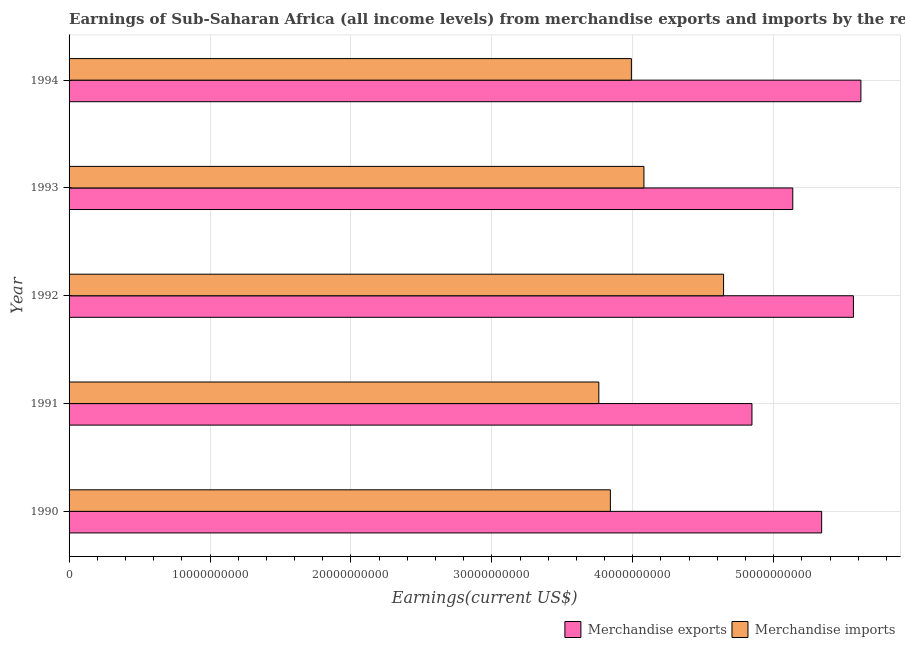How many bars are there on the 2nd tick from the top?
Give a very brief answer. 2. What is the label of the 1st group of bars from the top?
Your answer should be compact. 1994. What is the earnings from merchandise imports in 1994?
Ensure brevity in your answer.  3.99e+1. Across all years, what is the maximum earnings from merchandise imports?
Give a very brief answer. 4.64e+1. Across all years, what is the minimum earnings from merchandise imports?
Provide a succinct answer. 3.76e+1. In which year was the earnings from merchandise exports maximum?
Give a very brief answer. 1994. In which year was the earnings from merchandise imports minimum?
Offer a terse response. 1991. What is the total earnings from merchandise exports in the graph?
Give a very brief answer. 2.65e+11. What is the difference between the earnings from merchandise exports in 1990 and that in 1992?
Make the answer very short. -2.25e+09. What is the difference between the earnings from merchandise imports in 1994 and the earnings from merchandise exports in 1993?
Your response must be concise. -1.15e+1. What is the average earnings from merchandise exports per year?
Provide a succinct answer. 5.30e+1. In the year 1991, what is the difference between the earnings from merchandise exports and earnings from merchandise imports?
Provide a short and direct response. 1.09e+1. In how many years, is the earnings from merchandise imports greater than 24000000000 US$?
Your answer should be compact. 5. Is the difference between the earnings from merchandise exports in 1991 and 1993 greater than the difference between the earnings from merchandise imports in 1991 and 1993?
Make the answer very short. Yes. What is the difference between the highest and the second highest earnings from merchandise imports?
Give a very brief answer. 5.65e+09. What is the difference between the highest and the lowest earnings from merchandise imports?
Your answer should be very brief. 8.85e+09. Is the sum of the earnings from merchandise exports in 1993 and 1994 greater than the maximum earnings from merchandise imports across all years?
Keep it short and to the point. Yes. What does the 1st bar from the top in 1994 represents?
Offer a terse response. Merchandise imports. What does the 1st bar from the bottom in 1994 represents?
Keep it short and to the point. Merchandise exports. How many bars are there?
Your answer should be very brief. 10. What is the difference between two consecutive major ticks on the X-axis?
Ensure brevity in your answer.  1.00e+1. Does the graph contain grids?
Your response must be concise. Yes. Where does the legend appear in the graph?
Offer a terse response. Bottom right. How many legend labels are there?
Your answer should be compact. 2. What is the title of the graph?
Give a very brief answer. Earnings of Sub-Saharan Africa (all income levels) from merchandise exports and imports by the reporting economy. What is the label or title of the X-axis?
Your response must be concise. Earnings(current US$). What is the Earnings(current US$) of Merchandise exports in 1990?
Provide a succinct answer. 5.34e+1. What is the Earnings(current US$) in Merchandise imports in 1990?
Your answer should be compact. 3.84e+1. What is the Earnings(current US$) in Merchandise exports in 1991?
Keep it short and to the point. 4.85e+1. What is the Earnings(current US$) of Merchandise imports in 1991?
Provide a short and direct response. 3.76e+1. What is the Earnings(current US$) in Merchandise exports in 1992?
Give a very brief answer. 5.57e+1. What is the Earnings(current US$) of Merchandise imports in 1992?
Offer a terse response. 4.64e+1. What is the Earnings(current US$) of Merchandise exports in 1993?
Your answer should be compact. 5.14e+1. What is the Earnings(current US$) in Merchandise imports in 1993?
Your answer should be compact. 4.08e+1. What is the Earnings(current US$) in Merchandise exports in 1994?
Make the answer very short. 5.62e+1. What is the Earnings(current US$) in Merchandise imports in 1994?
Give a very brief answer. 3.99e+1. Across all years, what is the maximum Earnings(current US$) in Merchandise exports?
Your answer should be very brief. 5.62e+1. Across all years, what is the maximum Earnings(current US$) of Merchandise imports?
Your response must be concise. 4.64e+1. Across all years, what is the minimum Earnings(current US$) of Merchandise exports?
Give a very brief answer. 4.85e+1. Across all years, what is the minimum Earnings(current US$) in Merchandise imports?
Your response must be concise. 3.76e+1. What is the total Earnings(current US$) of Merchandise exports in the graph?
Your response must be concise. 2.65e+11. What is the total Earnings(current US$) of Merchandise imports in the graph?
Your answer should be very brief. 2.03e+11. What is the difference between the Earnings(current US$) in Merchandise exports in 1990 and that in 1991?
Offer a terse response. 4.95e+09. What is the difference between the Earnings(current US$) in Merchandise imports in 1990 and that in 1991?
Provide a succinct answer. 8.20e+08. What is the difference between the Earnings(current US$) of Merchandise exports in 1990 and that in 1992?
Provide a short and direct response. -2.25e+09. What is the difference between the Earnings(current US$) in Merchandise imports in 1990 and that in 1992?
Offer a very short reply. -8.03e+09. What is the difference between the Earnings(current US$) in Merchandise exports in 1990 and that in 1993?
Offer a terse response. 2.05e+09. What is the difference between the Earnings(current US$) of Merchandise imports in 1990 and that in 1993?
Provide a short and direct response. -2.38e+09. What is the difference between the Earnings(current US$) of Merchandise exports in 1990 and that in 1994?
Give a very brief answer. -2.78e+09. What is the difference between the Earnings(current US$) in Merchandise imports in 1990 and that in 1994?
Give a very brief answer. -1.49e+09. What is the difference between the Earnings(current US$) in Merchandise exports in 1991 and that in 1992?
Your answer should be very brief. -7.20e+09. What is the difference between the Earnings(current US$) of Merchandise imports in 1991 and that in 1992?
Make the answer very short. -8.85e+09. What is the difference between the Earnings(current US$) in Merchandise exports in 1991 and that in 1993?
Your answer should be very brief. -2.90e+09. What is the difference between the Earnings(current US$) in Merchandise imports in 1991 and that in 1993?
Offer a terse response. -3.20e+09. What is the difference between the Earnings(current US$) in Merchandise exports in 1991 and that in 1994?
Provide a succinct answer. -7.73e+09. What is the difference between the Earnings(current US$) of Merchandise imports in 1991 and that in 1994?
Give a very brief answer. -2.31e+09. What is the difference between the Earnings(current US$) in Merchandise exports in 1992 and that in 1993?
Your answer should be compact. 4.30e+09. What is the difference between the Earnings(current US$) of Merchandise imports in 1992 and that in 1993?
Provide a short and direct response. 5.65e+09. What is the difference between the Earnings(current US$) in Merchandise exports in 1992 and that in 1994?
Provide a succinct answer. -5.30e+08. What is the difference between the Earnings(current US$) of Merchandise imports in 1992 and that in 1994?
Provide a succinct answer. 6.54e+09. What is the difference between the Earnings(current US$) of Merchandise exports in 1993 and that in 1994?
Provide a short and direct response. -4.83e+09. What is the difference between the Earnings(current US$) of Merchandise imports in 1993 and that in 1994?
Keep it short and to the point. 8.90e+08. What is the difference between the Earnings(current US$) in Merchandise exports in 1990 and the Earnings(current US$) in Merchandise imports in 1991?
Offer a terse response. 1.58e+1. What is the difference between the Earnings(current US$) in Merchandise exports in 1990 and the Earnings(current US$) in Merchandise imports in 1992?
Your response must be concise. 6.96e+09. What is the difference between the Earnings(current US$) of Merchandise exports in 1990 and the Earnings(current US$) of Merchandise imports in 1993?
Your answer should be very brief. 1.26e+1. What is the difference between the Earnings(current US$) of Merchandise exports in 1990 and the Earnings(current US$) of Merchandise imports in 1994?
Ensure brevity in your answer.  1.35e+1. What is the difference between the Earnings(current US$) in Merchandise exports in 1991 and the Earnings(current US$) in Merchandise imports in 1992?
Give a very brief answer. 2.01e+09. What is the difference between the Earnings(current US$) of Merchandise exports in 1991 and the Earnings(current US$) of Merchandise imports in 1993?
Keep it short and to the point. 7.66e+09. What is the difference between the Earnings(current US$) in Merchandise exports in 1991 and the Earnings(current US$) in Merchandise imports in 1994?
Your answer should be compact. 8.56e+09. What is the difference between the Earnings(current US$) in Merchandise exports in 1992 and the Earnings(current US$) in Merchandise imports in 1993?
Ensure brevity in your answer.  1.49e+1. What is the difference between the Earnings(current US$) of Merchandise exports in 1992 and the Earnings(current US$) of Merchandise imports in 1994?
Make the answer very short. 1.58e+1. What is the difference between the Earnings(current US$) in Merchandise exports in 1993 and the Earnings(current US$) in Merchandise imports in 1994?
Make the answer very short. 1.15e+1. What is the average Earnings(current US$) of Merchandise exports per year?
Offer a terse response. 5.30e+1. What is the average Earnings(current US$) of Merchandise imports per year?
Ensure brevity in your answer.  4.06e+1. In the year 1990, what is the difference between the Earnings(current US$) in Merchandise exports and Earnings(current US$) in Merchandise imports?
Provide a succinct answer. 1.50e+1. In the year 1991, what is the difference between the Earnings(current US$) in Merchandise exports and Earnings(current US$) in Merchandise imports?
Keep it short and to the point. 1.09e+1. In the year 1992, what is the difference between the Earnings(current US$) of Merchandise exports and Earnings(current US$) of Merchandise imports?
Provide a short and direct response. 9.21e+09. In the year 1993, what is the difference between the Earnings(current US$) in Merchandise exports and Earnings(current US$) in Merchandise imports?
Your response must be concise. 1.06e+1. In the year 1994, what is the difference between the Earnings(current US$) in Merchandise exports and Earnings(current US$) in Merchandise imports?
Offer a terse response. 1.63e+1. What is the ratio of the Earnings(current US$) in Merchandise exports in 1990 to that in 1991?
Offer a very short reply. 1.1. What is the ratio of the Earnings(current US$) in Merchandise imports in 1990 to that in 1991?
Make the answer very short. 1.02. What is the ratio of the Earnings(current US$) in Merchandise exports in 1990 to that in 1992?
Provide a short and direct response. 0.96. What is the ratio of the Earnings(current US$) in Merchandise imports in 1990 to that in 1992?
Your response must be concise. 0.83. What is the ratio of the Earnings(current US$) of Merchandise exports in 1990 to that in 1993?
Your response must be concise. 1.04. What is the ratio of the Earnings(current US$) in Merchandise imports in 1990 to that in 1993?
Provide a short and direct response. 0.94. What is the ratio of the Earnings(current US$) in Merchandise exports in 1990 to that in 1994?
Give a very brief answer. 0.95. What is the ratio of the Earnings(current US$) of Merchandise imports in 1990 to that in 1994?
Offer a very short reply. 0.96. What is the ratio of the Earnings(current US$) of Merchandise exports in 1991 to that in 1992?
Offer a terse response. 0.87. What is the ratio of the Earnings(current US$) in Merchandise imports in 1991 to that in 1992?
Offer a terse response. 0.81. What is the ratio of the Earnings(current US$) in Merchandise exports in 1991 to that in 1993?
Offer a terse response. 0.94. What is the ratio of the Earnings(current US$) of Merchandise imports in 1991 to that in 1993?
Provide a succinct answer. 0.92. What is the ratio of the Earnings(current US$) in Merchandise exports in 1991 to that in 1994?
Ensure brevity in your answer.  0.86. What is the ratio of the Earnings(current US$) of Merchandise imports in 1991 to that in 1994?
Your answer should be very brief. 0.94. What is the ratio of the Earnings(current US$) in Merchandise exports in 1992 to that in 1993?
Ensure brevity in your answer.  1.08. What is the ratio of the Earnings(current US$) in Merchandise imports in 1992 to that in 1993?
Make the answer very short. 1.14. What is the ratio of the Earnings(current US$) in Merchandise exports in 1992 to that in 1994?
Provide a succinct answer. 0.99. What is the ratio of the Earnings(current US$) of Merchandise imports in 1992 to that in 1994?
Provide a succinct answer. 1.16. What is the ratio of the Earnings(current US$) of Merchandise exports in 1993 to that in 1994?
Keep it short and to the point. 0.91. What is the ratio of the Earnings(current US$) of Merchandise imports in 1993 to that in 1994?
Offer a very short reply. 1.02. What is the difference between the highest and the second highest Earnings(current US$) of Merchandise exports?
Ensure brevity in your answer.  5.30e+08. What is the difference between the highest and the second highest Earnings(current US$) in Merchandise imports?
Give a very brief answer. 5.65e+09. What is the difference between the highest and the lowest Earnings(current US$) of Merchandise exports?
Your response must be concise. 7.73e+09. What is the difference between the highest and the lowest Earnings(current US$) in Merchandise imports?
Provide a succinct answer. 8.85e+09. 